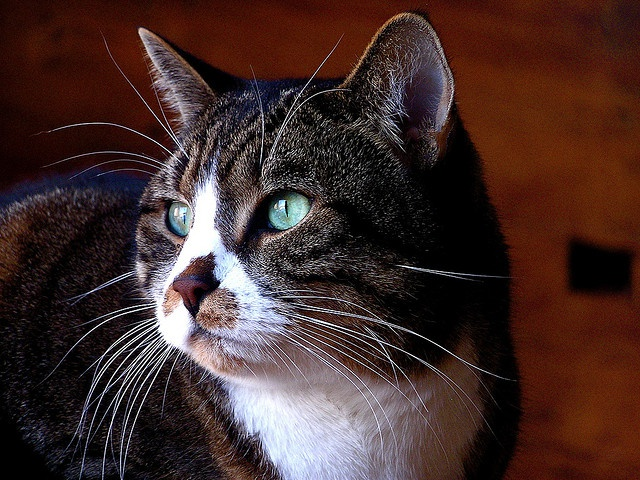Describe the objects in this image and their specific colors. I can see a cat in black, gray, lavender, and darkgray tones in this image. 